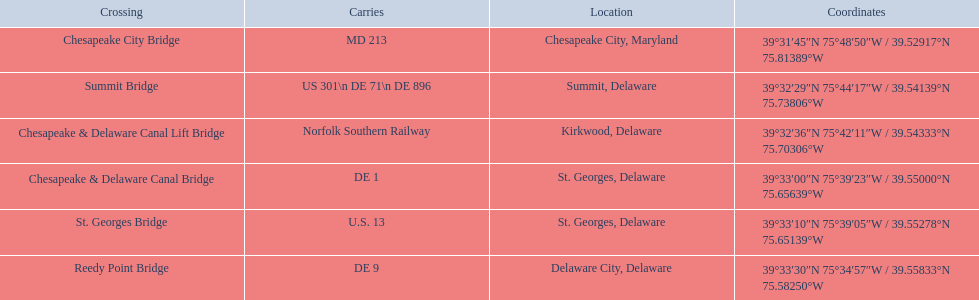Which bridges are in delaware? Summit Bridge, Chesapeake & Delaware Canal Lift Bridge, Chesapeake & Delaware Canal Bridge, St. Georges Bridge, Reedy Point Bridge. Which delaware bridge carries de 9? Reedy Point Bridge. 